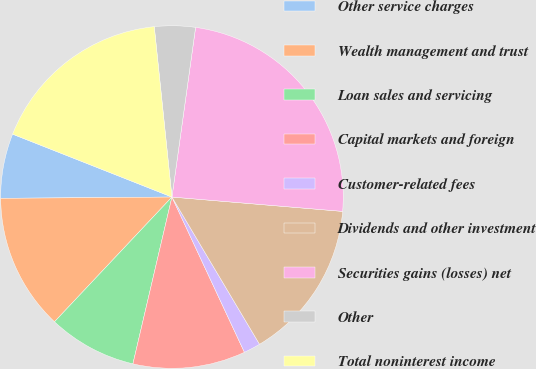Convert chart. <chart><loc_0><loc_0><loc_500><loc_500><pie_chart><fcel>Other service charges<fcel>Wealth management and trust<fcel>Loan sales and servicing<fcel>Capital markets and foreign<fcel>Customer-related fees<fcel>Dividends and other investment<fcel>Securities gains (losses) net<fcel>Other<fcel>Total noninterest income<nl><fcel>6.1%<fcel>12.86%<fcel>8.36%<fcel>10.61%<fcel>1.59%<fcel>15.12%<fcel>24.13%<fcel>3.85%<fcel>17.37%<nl></chart> 